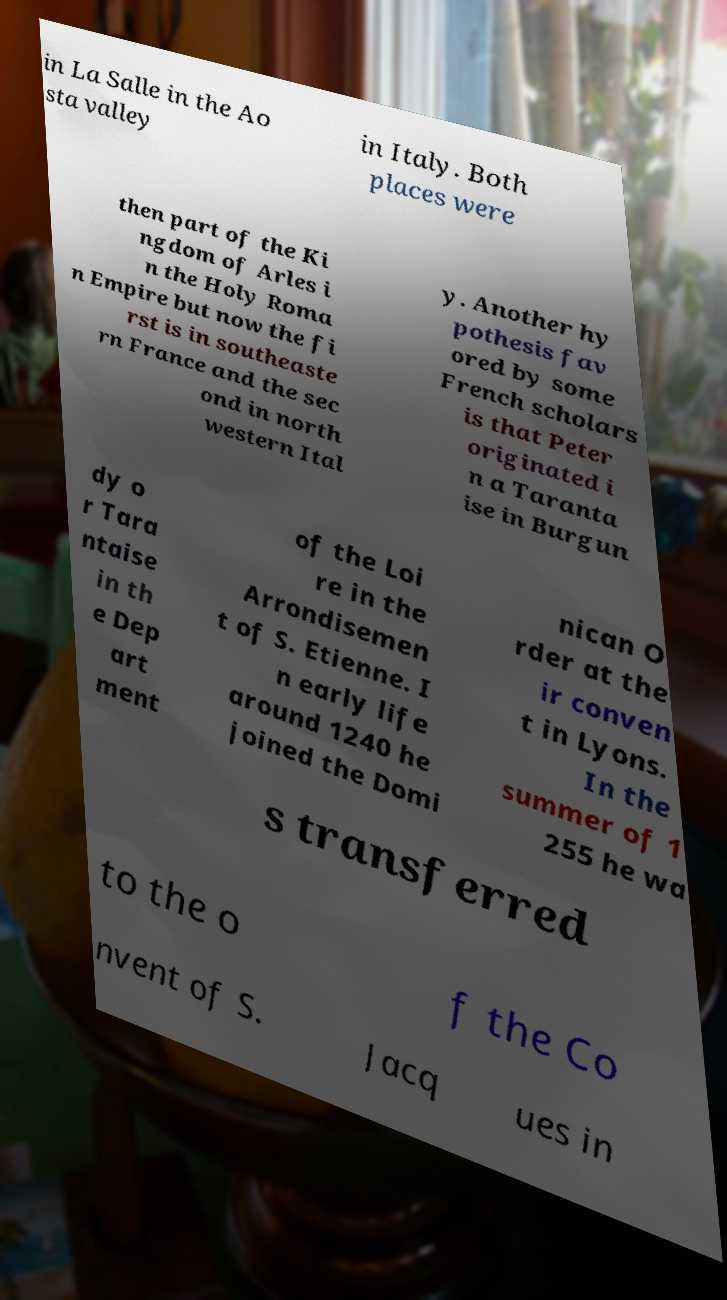There's text embedded in this image that I need extracted. Can you transcribe it verbatim? in La Salle in the Ao sta valley in Italy. Both places were then part of the Ki ngdom of Arles i n the Holy Roma n Empire but now the fi rst is in southeaste rn France and the sec ond in north western Ital y. Another hy pothesis fav ored by some French scholars is that Peter originated i n a Taranta ise in Burgun dy o r Tara ntaise in th e Dep art ment of the Loi re in the Arrondisemen t of S. Etienne. I n early life around 1240 he joined the Domi nican O rder at the ir conven t in Lyons. In the summer of 1 255 he wa s transferred to the o f the Co nvent of S. Jacq ues in 